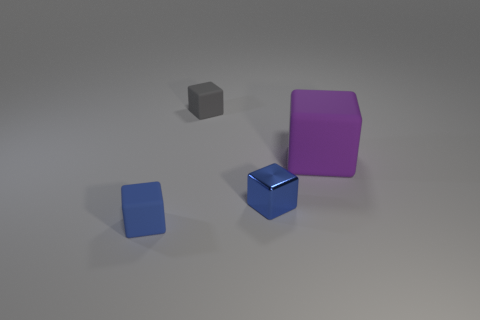Subtract all cyan cubes. Subtract all yellow cylinders. How many cubes are left? 4 Add 2 rubber objects. How many objects exist? 6 Subtract all small green cylinders. Subtract all small blue rubber cubes. How many objects are left? 3 Add 4 large objects. How many large objects are left? 5 Add 3 large brown cubes. How many large brown cubes exist? 3 Subtract 0 gray cylinders. How many objects are left? 4 